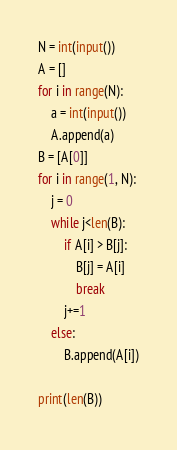<code> <loc_0><loc_0><loc_500><loc_500><_Python_>N = int(input())
A = []
for i in range(N):
    a = int(input())
    A.append(a)
B = [A[0]]
for i in range(1, N):
    j = 0
    while j<len(B):
        if A[i] > B[j]:
            B[j] = A[i]
            break
        j+=1
    else:
        B.append(A[i])

print(len(B))</code> 